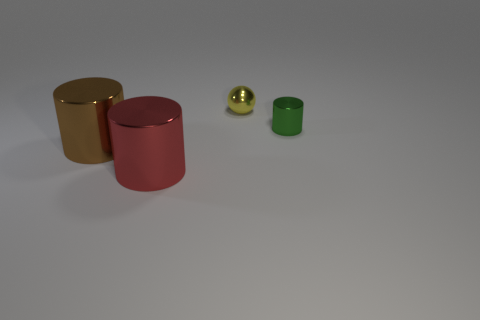Are there fewer tiny green cylinders behind the green cylinder than balls that are behind the big brown metal thing?
Ensure brevity in your answer.  Yes. What is the color of the tiny metal cylinder?
Make the answer very short. Green. Are there any balls that have the same color as the tiny cylinder?
Offer a terse response. No. There is a small shiny object on the left side of the cylinder that is behind the large metallic thing behind the red object; what shape is it?
Your response must be concise. Sphere. There is a small object to the right of the tiny sphere; what is it made of?
Provide a short and direct response. Metal. There is a cylinder that is right of the small object on the left side of the small cylinder right of the red thing; how big is it?
Offer a very short reply. Small. There is a red metal cylinder; is it the same size as the object behind the small green object?
Your answer should be very brief. No. What is the color of the tiny thing that is behind the small green object?
Ensure brevity in your answer.  Yellow. What is the shape of the object behind the tiny cylinder?
Your answer should be compact. Sphere. What number of red objects are either small shiny objects or metal things?
Keep it short and to the point. 1. 